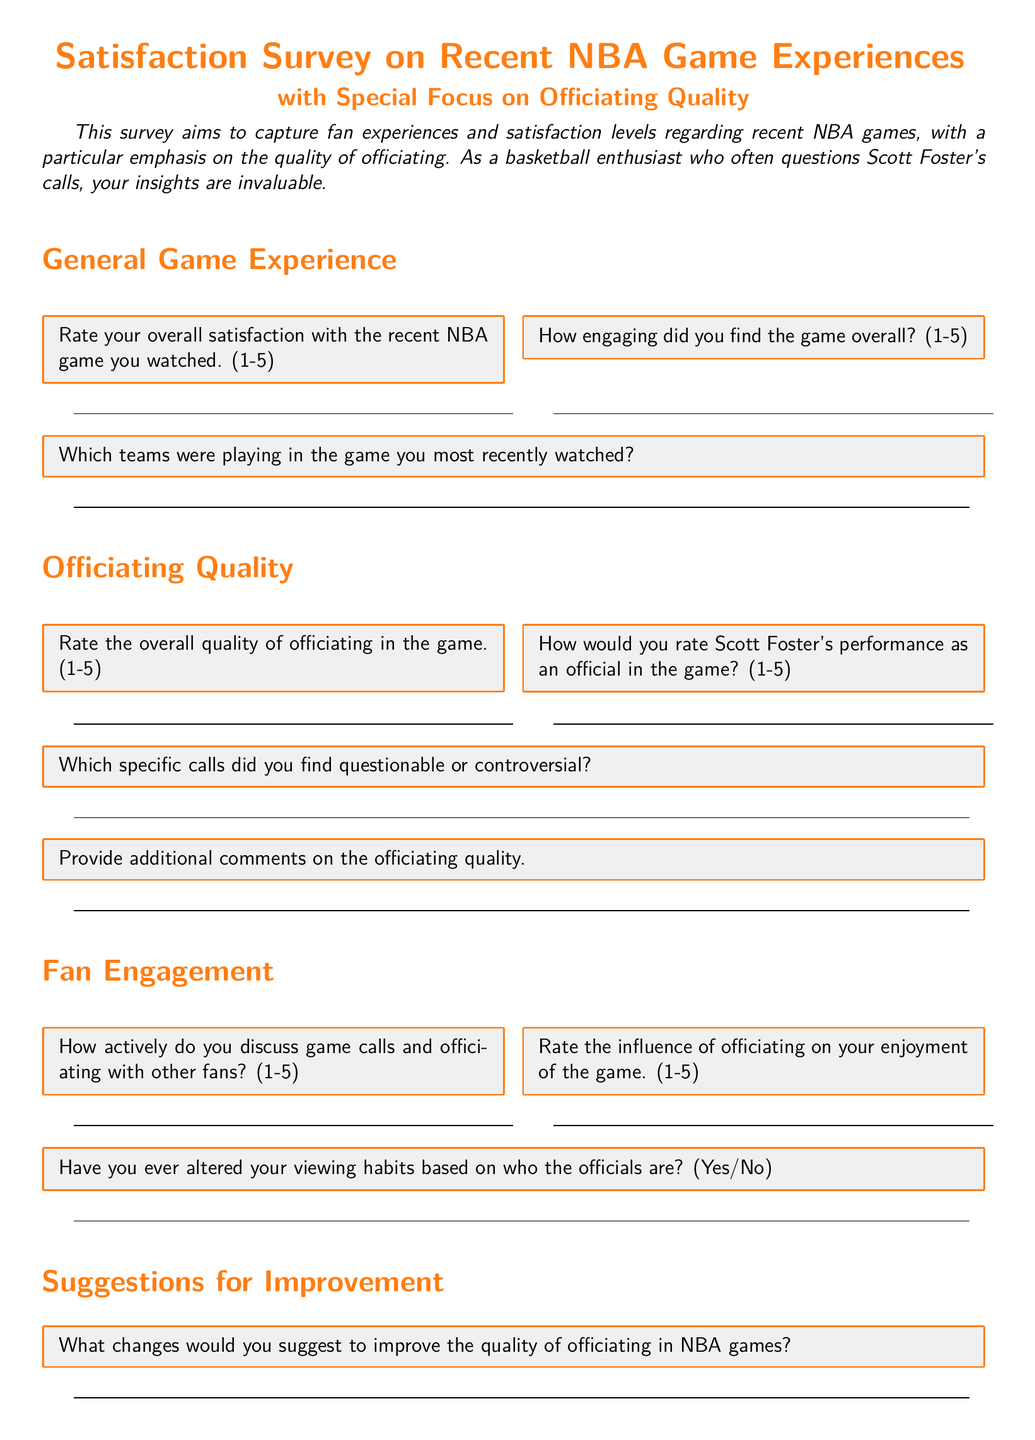what is the title of the survey? The title of the survey is specified in the document as "Satisfaction Survey on Recent NBA Game Experiences."
Answer: Satisfaction Survey on Recent NBA Game Experiences what is the main focus of the survey? The survey has a particular emphasis, as stated in the document, which is on the "Quality of officiating."
Answer: Quality of officiating how many teams are mentioned in the survey? The survey does not specify a number of teams; instead, it asks for the teams that were playing, implying a variable number based on the respondent's input.
Answer: Variable what rating scale is used for overall satisfaction? The document specifies a rating scale from 1 to 5 for various satisfaction questions.
Answer: 1-5 what specific official's performance is rated in the survey? The survey specifically asks about Scott Foster's performance as an official.
Answer: Scott Foster what type of questions does the survey include about fan engagement? The survey includes questions that ask about how fans discuss game calls and their feelings towards officiating.
Answer: Discussion and feelings what is one suggestion requested from respondents in the survey? The survey explicitly asks participants for suggestions to improve the quality of officiating in NBA games.
Answer: Quality of officiating how are the questions in the survey organized? The questions in the survey are organized into sections such as General Game Experience, Officiating Quality, Fan Engagement, and Suggestions for Improvement.
Answer: Sections how would you refer to the performance rating question style in the survey? The performance rating question style in the survey is referred to as a Likert scale rating question.
Answer: Likert scale rating 